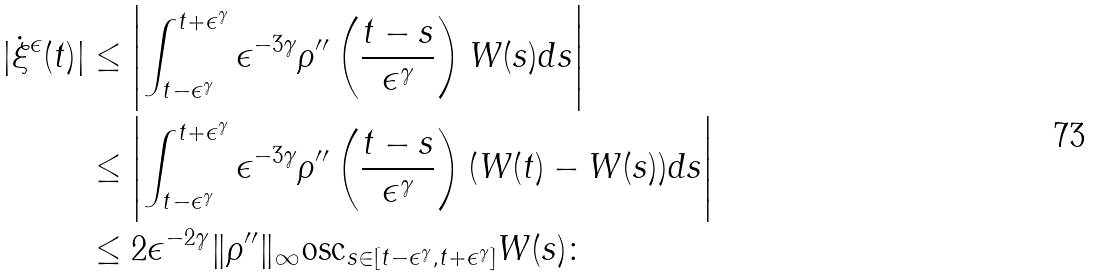<formula> <loc_0><loc_0><loc_500><loc_500>| \dot { \xi } ^ { \epsilon } ( t ) | & \leq \left | \int _ { t - \epsilon ^ { \gamma } } ^ { t + \epsilon ^ { \gamma } } \epsilon ^ { - 3 \gamma } \rho ^ { \prime \prime } \left ( \frac { t - s } { \epsilon ^ { \gamma } } \right ) W ( s ) d s \right | \\ & \leq \left | \int _ { t - \epsilon ^ { \gamma } } ^ { t + \epsilon ^ { \gamma } } \epsilon ^ { - 3 \gamma } \rho ^ { \prime \prime } \left ( \frac { t - s } { \epsilon ^ { \gamma } } \right ) ( W ( t ) - W ( s ) ) d s \right | \\ & \leq 2 \epsilon ^ { - 2 \gamma } \| \rho ^ { \prime \prime } \| _ { \infty } \text {osc} _ { s \in [ t - \epsilon ^ { \gamma } , t + \epsilon ^ { \gamma } ] } W ( s ) \colon</formula> 